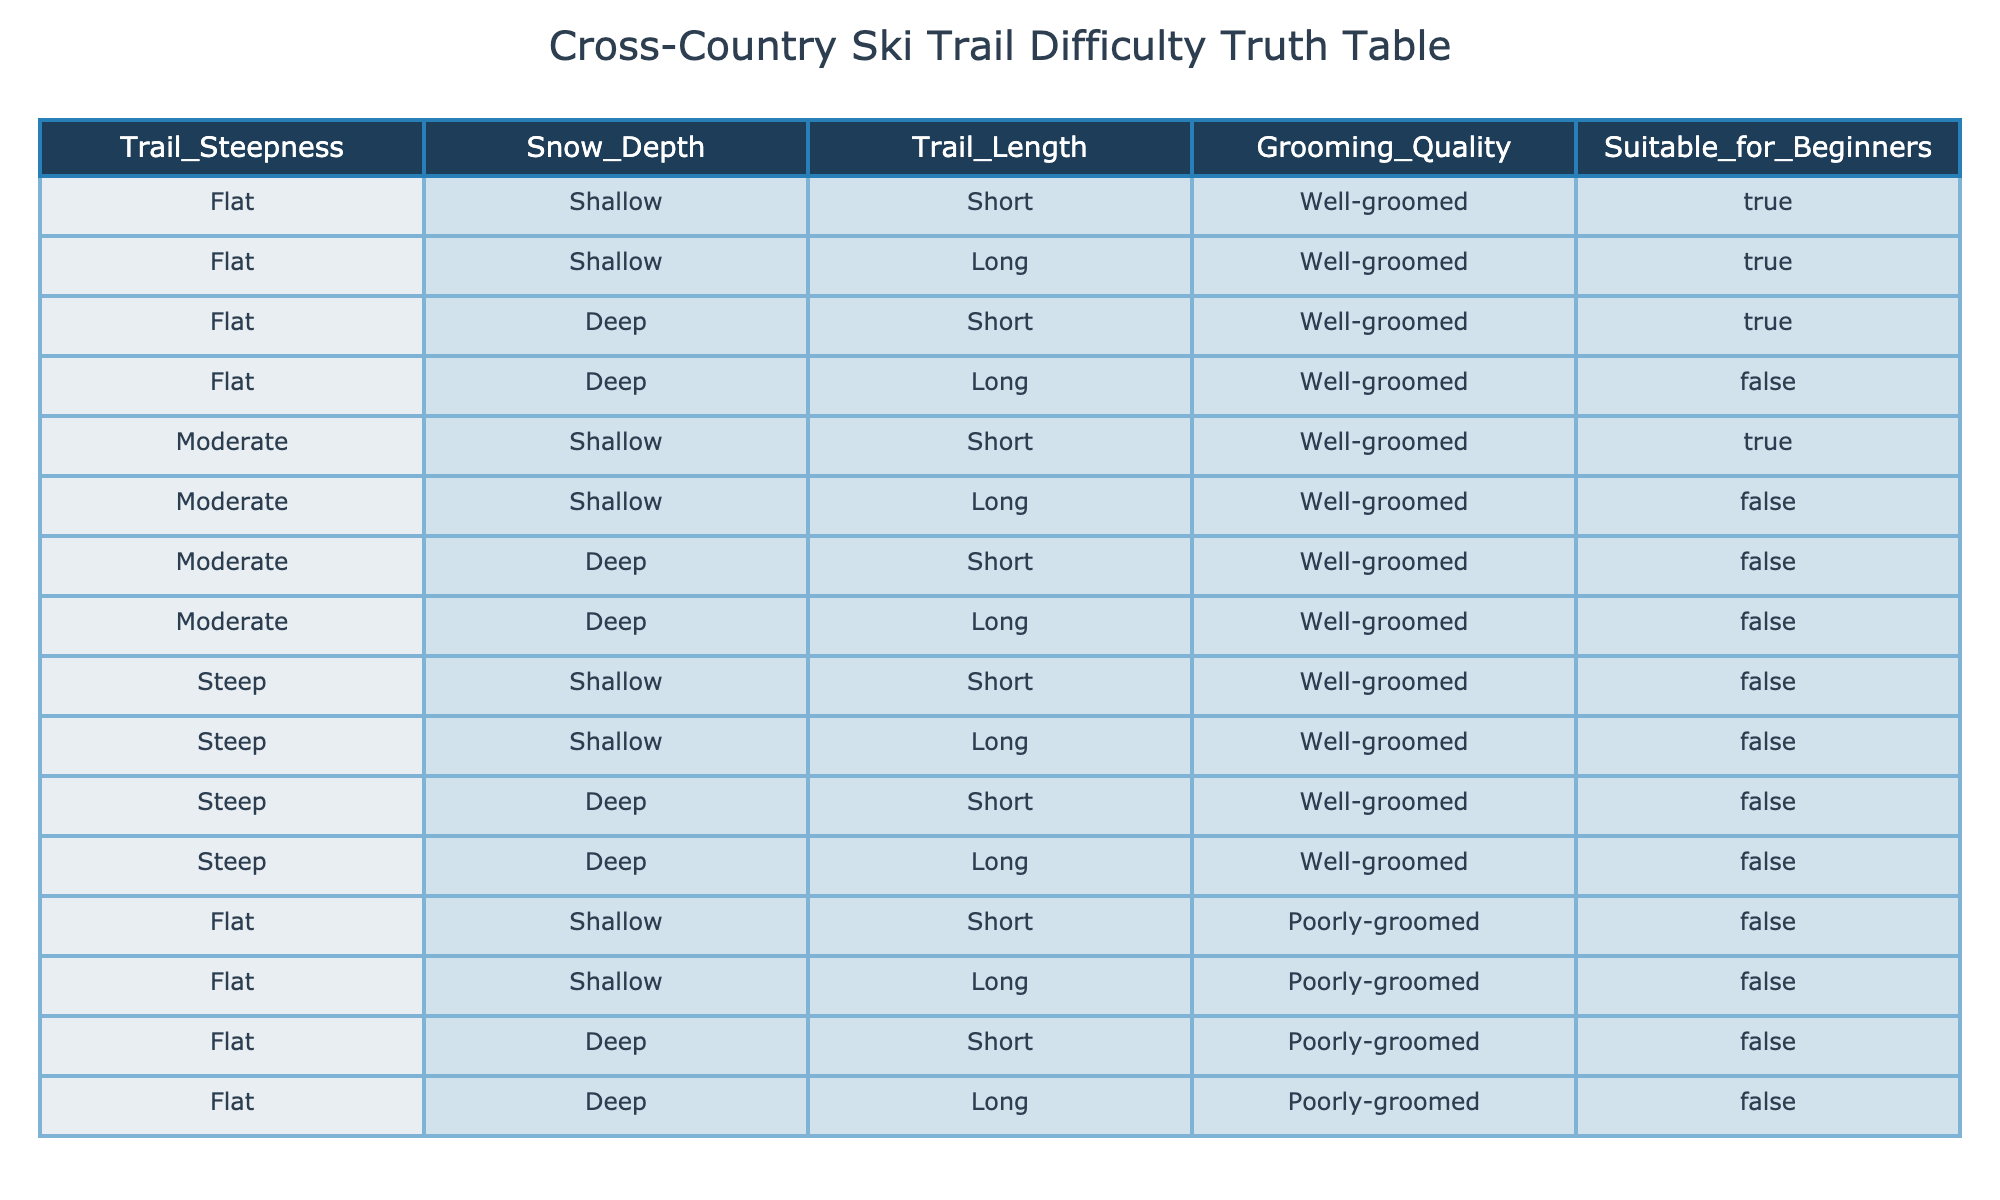What is the grooming quality of the trail that is flat, shallow, and short? According to the table, the trail with attributes flat, shallow, and short is labeled as well-groomed under the grooming quality column.
Answer: Well-groomed How many trails in the table are suitable for beginners? By reviewing the suitable for beginners column, we see there are 5 entries marked as TRUE, indicating that those trails are suitable for beginners.
Answer: 5 Is a flat, deep, long trail suitable for beginners? The table indicates that the flat, deep, long trail has a FALSE value for the suitable for beginners column. Thus, it is not suitable.
Answer: No What is the grooming quality of the trails that are steep? Looking at the grooming quality column for the steep trails, all rows marked steep show a grooming quality of well-groomed but still result in unsuitable conditions for beginners.
Answer: Well-groomed What is the total number of trails that are both poorly-groomed and not suitable for beginners? In the table, there are 4 trails listed with poorly-groomed quality, and all of them have a FALSE label in the suitable for beginners column. Therefore, the total number is 4.
Answer: 4 Are moderate, shallow, long trails suitable for beginners? The moderate, shallow, long trail has a FALSE value for suitability for beginners according to the table, indicating it is not considered suitable.
Answer: No What proportion of all trails is suitable for beginners? There are 5 trails suitable for beginners out of a total of 16 trails listed in the table. To find the proportion, we do 5/16 = 0.3125 or about 31.25%.
Answer: 31.25% How many trails are both steep and poorly-groomed? The table shows that 4 trails have the steep attribute and are also labeled as poorly-groomed, confirming they meet both criteria.
Answer: 4 What is the grooming quality of trails that are flat, shallow, and deep? For flat, shallow trails, 2 out of 4 are well-groomed while both flat deep variants are poorly-groomed. Therefore, among flat and shallow, the grooming quality varies, showing a mix.
Answer: Mixed quality 